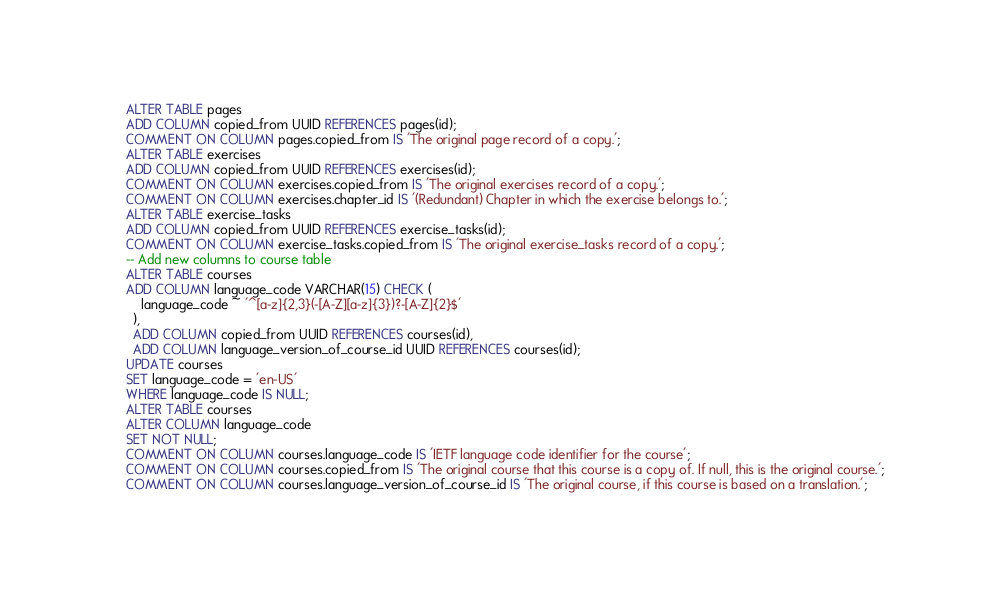Convert code to text. <code><loc_0><loc_0><loc_500><loc_500><_SQL_>ALTER TABLE pages
ADD COLUMN copied_from UUID REFERENCES pages(id);
COMMENT ON COLUMN pages.copied_from IS 'The original page record of a copy.';
ALTER TABLE exercises
ADD COLUMN copied_from UUID REFERENCES exercises(id);
COMMENT ON COLUMN exercises.copied_from IS 'The original exercises record of a copy.';
COMMENT ON COLUMN exercises.chapter_id IS '(Redundant) Chapter in which the exercise belongs to.';
ALTER TABLE exercise_tasks
ADD COLUMN copied_from UUID REFERENCES exercise_tasks(id);
COMMENT ON COLUMN exercise_tasks.copied_from IS 'The original exercise_tasks record of a copy.';
-- Add new columns to course table
ALTER TABLE courses
ADD COLUMN language_code VARCHAR(15) CHECK (
    language_code ~ '^[a-z]{2,3}(-[A-Z][a-z]{3})?-[A-Z]{2}$'
  ),
  ADD COLUMN copied_from UUID REFERENCES courses(id),
  ADD COLUMN language_version_of_course_id UUID REFERENCES courses(id);
UPDATE courses
SET language_code = 'en-US'
WHERE language_code IS NULL;
ALTER TABLE courses
ALTER COLUMN language_code
SET NOT NULL;
COMMENT ON COLUMN courses.language_code IS 'IETF language code identifier for the course';
COMMENT ON COLUMN courses.copied_from IS 'The original course that this course is a copy of. If null, this is the original course.';
COMMENT ON COLUMN courses.language_version_of_course_id IS 'The original course, if this course is based on a translation.';
</code> 